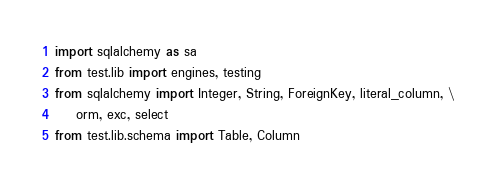Convert code to text. <code><loc_0><loc_0><loc_500><loc_500><_Python_>import sqlalchemy as sa
from test.lib import engines, testing
from sqlalchemy import Integer, String, ForeignKey, literal_column, \
    orm, exc, select
from test.lib.schema import Table, Column</code> 